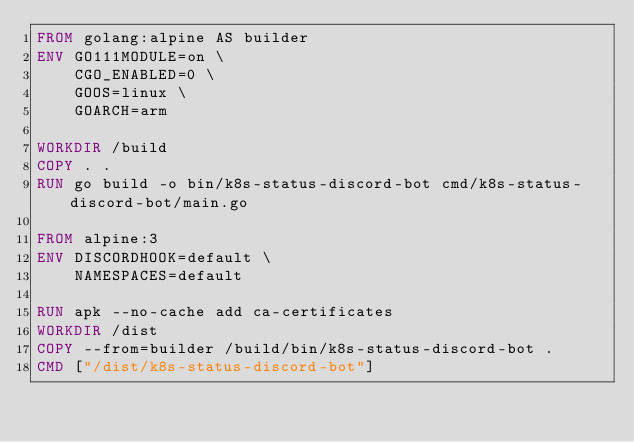Convert code to text. <code><loc_0><loc_0><loc_500><loc_500><_Dockerfile_>FROM golang:alpine AS builder
ENV GO111MODULE=on \
    CGO_ENABLED=0 \
    GOOS=linux \
    GOARCH=arm

WORKDIR /build
COPY . .
RUN go build -o bin/k8s-status-discord-bot cmd/k8s-status-discord-bot/main.go

FROM alpine:3
ENV DISCORDHOOK=default \
    NAMESPACES=default

RUN apk --no-cache add ca-certificates
WORKDIR /dist
COPY --from=builder /build/bin/k8s-status-discord-bot .
CMD ["/dist/k8s-status-discord-bot"]
</code> 